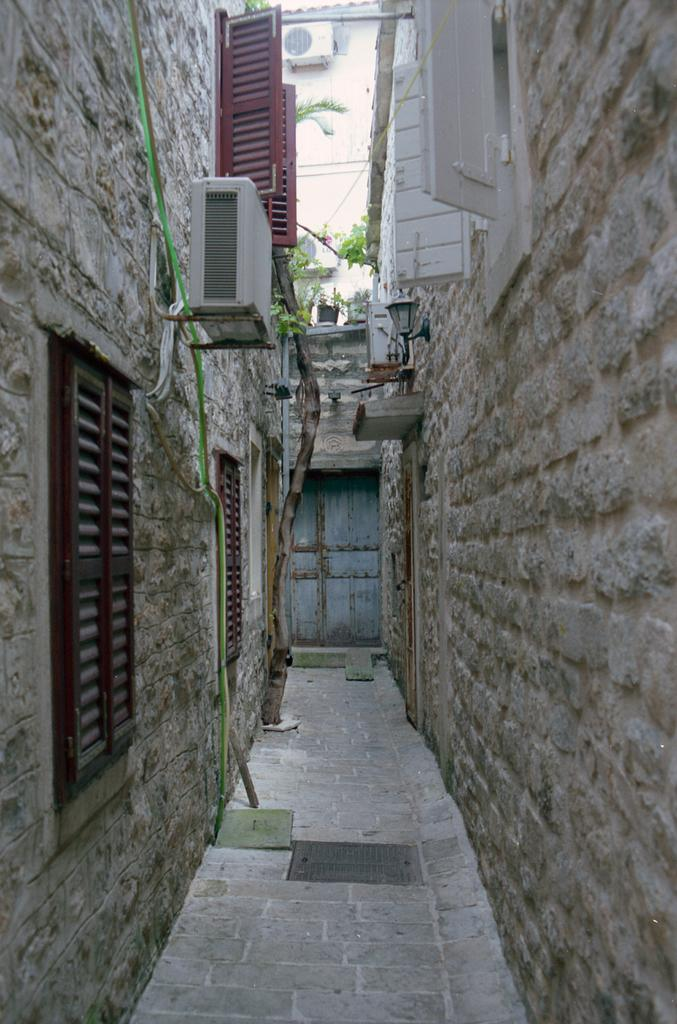What is the main feature in the middle of the image? There is a path in the middle of the image. What surrounds the path? The path is between building walls. What can be seen on the building walls? The building walls have windows. What is visible in the background of the image? There is a door visible in the background of the image. Can you see a flame burning on the path in the image? There is no flame present in the image; it features a path between building walls with windows and a door visible in the background. 